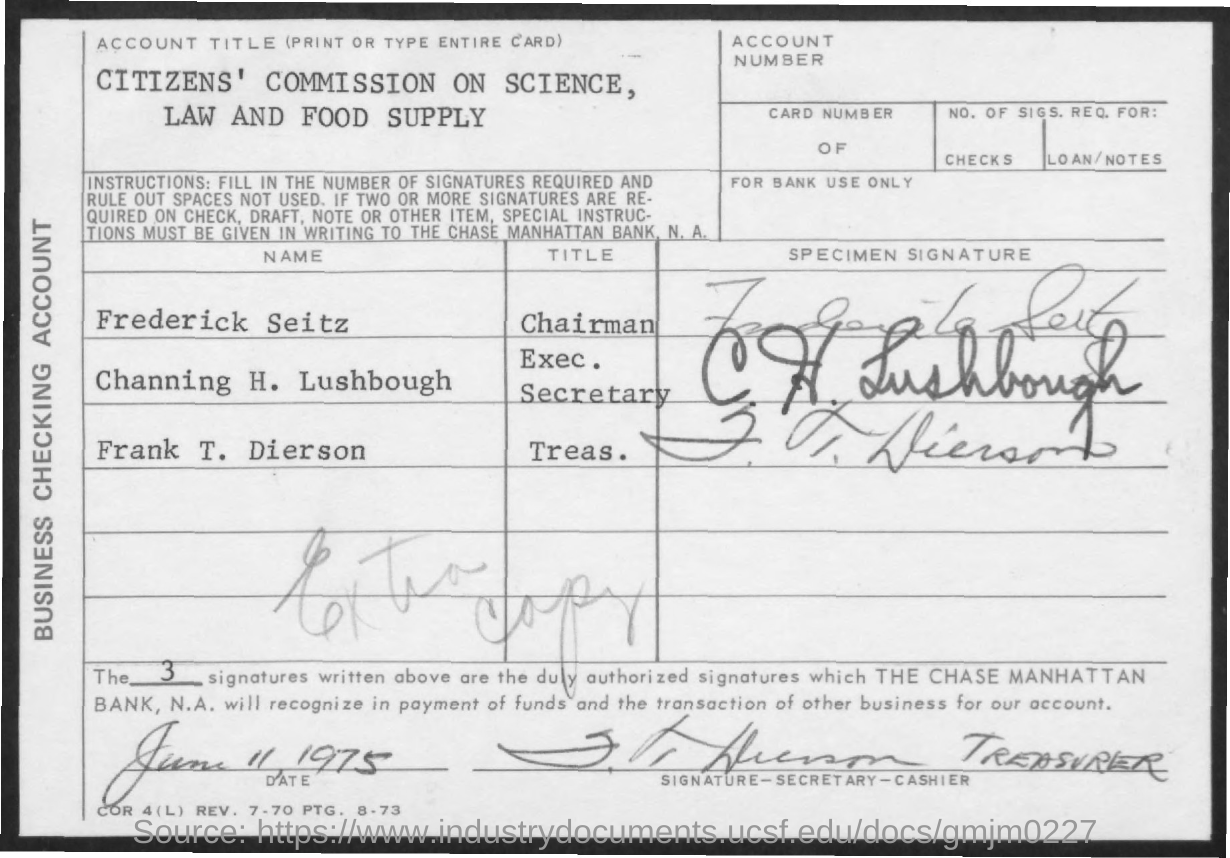What is the date mentioned ?
Ensure brevity in your answer.  June 11 1975. What is the title mentioned for frederick seitz ?
Your response must be concise. Chairman. What is the title mentioned for channing h. lushbough ?
Give a very brief answer. Exec. Secretary. What is the name of the title mentioned for frank t. dierson ?
Your answer should be very brief. Treas. 